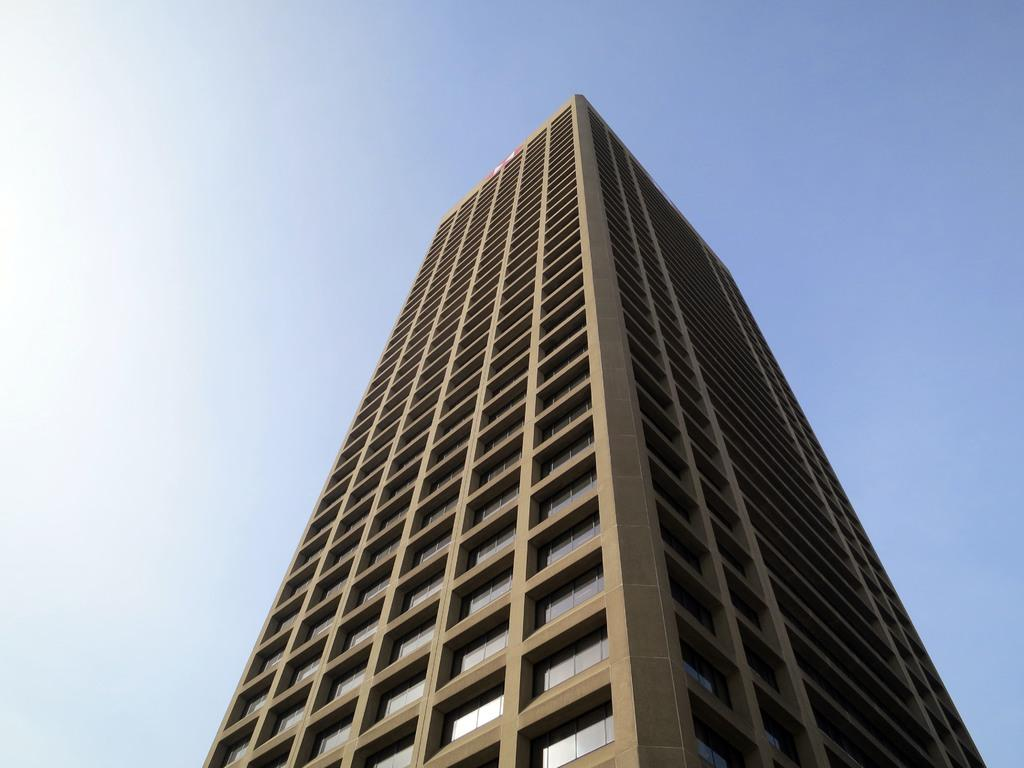Where was the image taken? The image is taken outdoors. What can be seen at the top of the image? The sky is visible at the top of the image. What is the main structure in the middle of the image? There is a building in the middle of the image. What are some features of the building? The building has walls, windows, and a roof. Can you see the tail of the animal in the image? There is no animal with a tail present in the image. What observation can be made about the building's structural integrity in the image? The image does not provide any information about the building's structural integrity. 